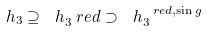<formula> <loc_0><loc_0><loc_500><loc_500>\ h _ { 3 } \supseteq \ h _ { 3 } ^ { \ } r e d \supset \ h _ { 3 } ^ { \ r e d , \sin g }</formula> 